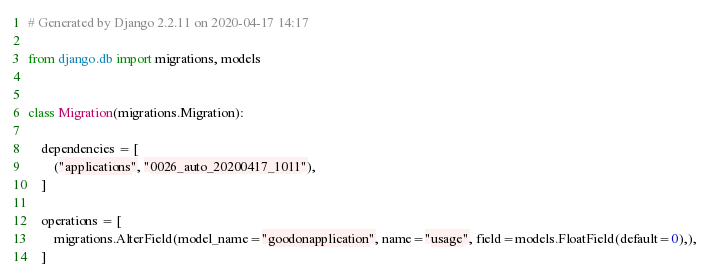Convert code to text. <code><loc_0><loc_0><loc_500><loc_500><_Python_># Generated by Django 2.2.11 on 2020-04-17 14:17

from django.db import migrations, models


class Migration(migrations.Migration):

    dependencies = [
        ("applications", "0026_auto_20200417_1011"),
    ]

    operations = [
        migrations.AlterField(model_name="goodonapplication", name="usage", field=models.FloatField(default=0),),
    ]
</code> 